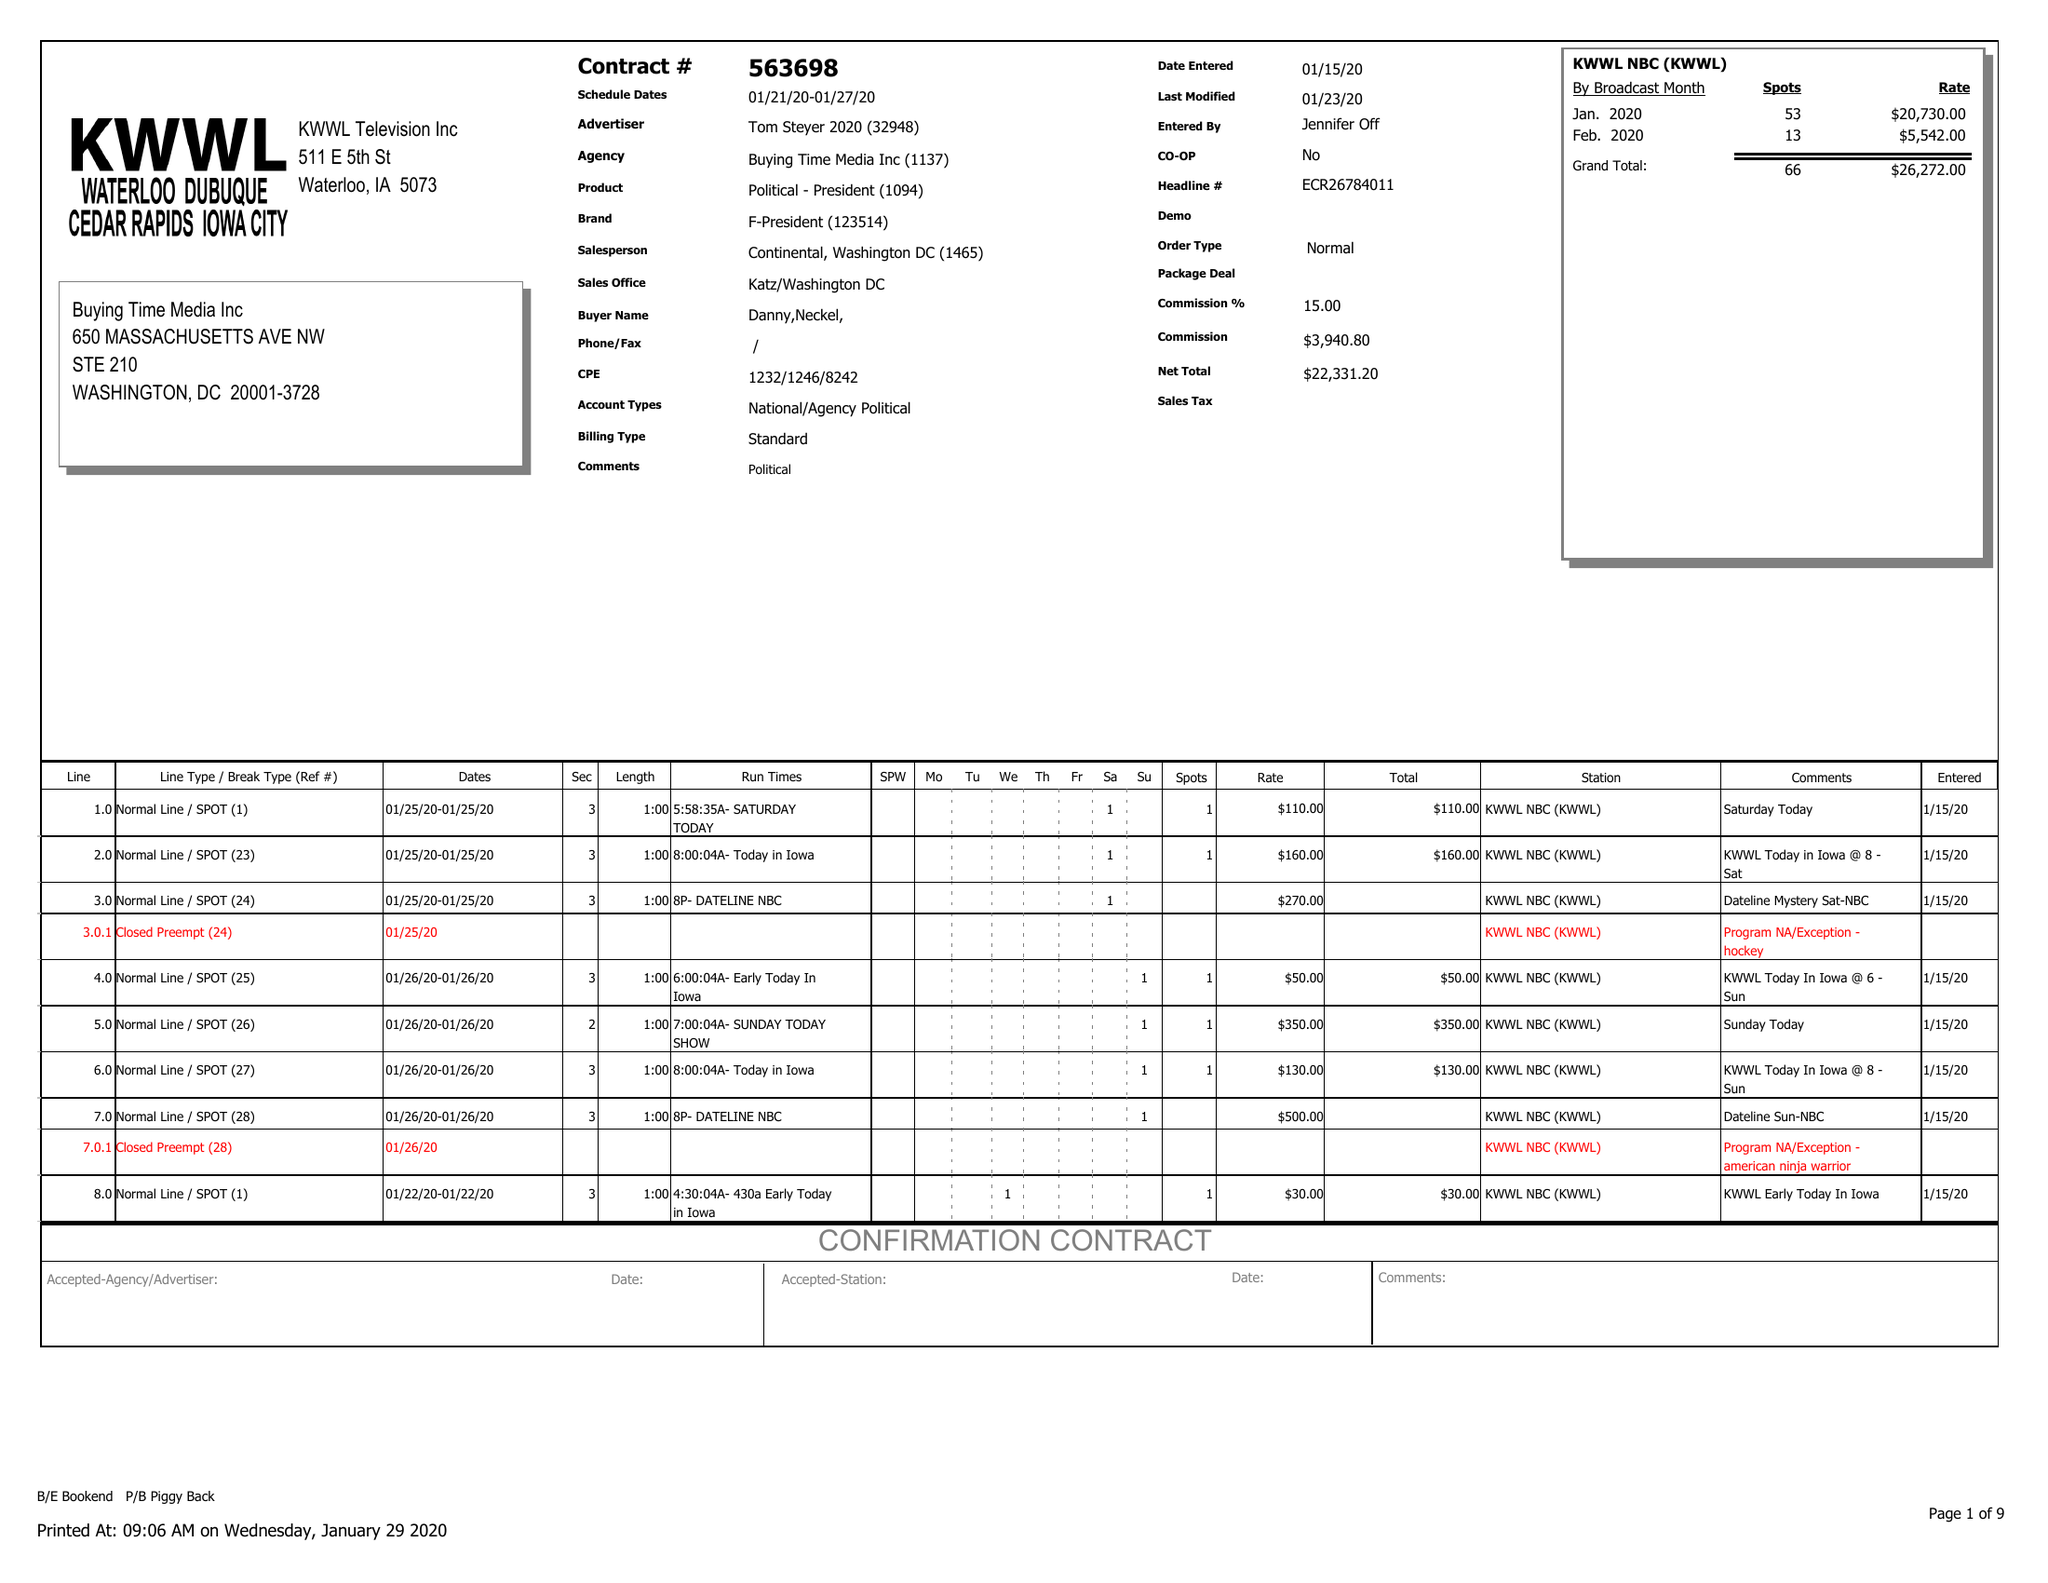What is the value for the flight_to?
Answer the question using a single word or phrase. 01/27/20 